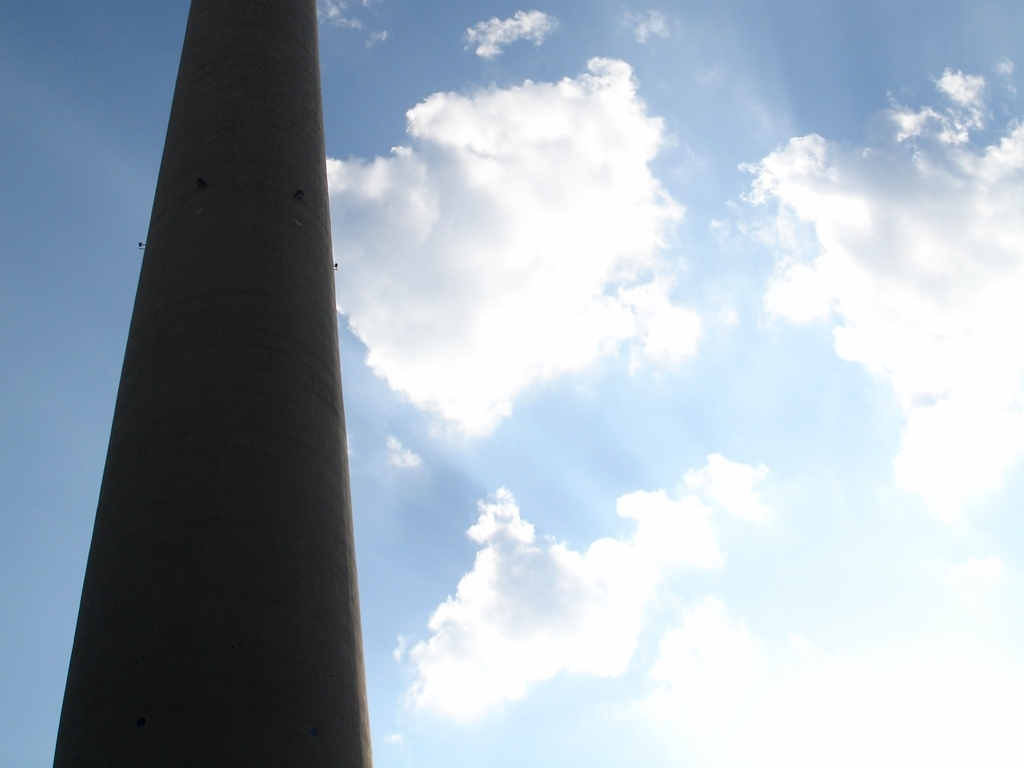Does the photo lack sharpness? The photo appears to be sufficiently sharp, especially considering the elements in focus such as the cloud edges and the surface texture of the structure. However, given the subtle variations in lighting and the soft background sky, the sharpness may not seem optimal to all viewers, depending on their expectations or the display device. 